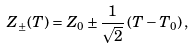<formula> <loc_0><loc_0><loc_500><loc_500>Z _ { \pm } ( T ) = Z _ { 0 } \pm \frac { 1 } { \sqrt { 2 } } \, ( T - T _ { 0 } ) \, ,</formula> 